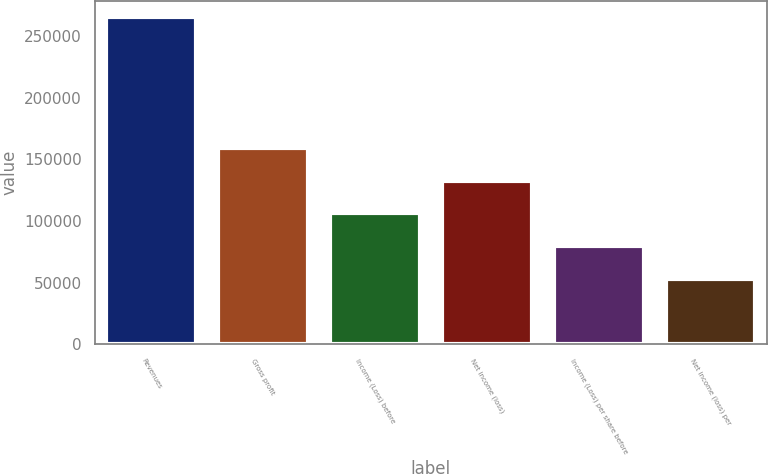Convert chart to OTSL. <chart><loc_0><loc_0><loc_500><loc_500><bar_chart><fcel>Revenues<fcel>Gross profit<fcel>Income (Loss) before<fcel>Net income (loss)<fcel>Income (Loss) per share before<fcel>Net income (loss) per<nl><fcel>265536<fcel>159322<fcel>106214<fcel>132768<fcel>79660.9<fcel>53107.2<nl></chart> 